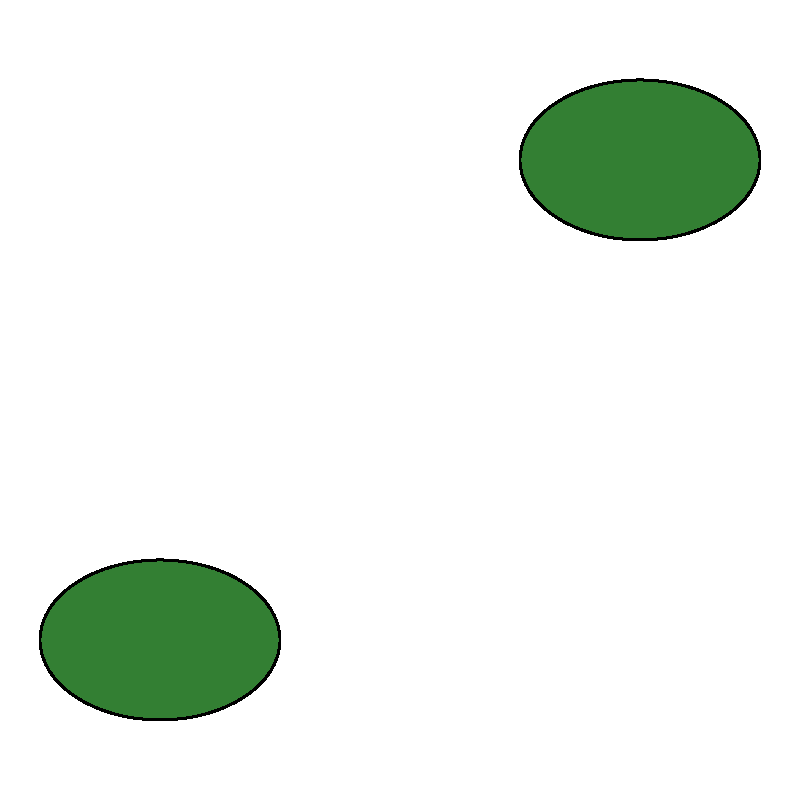Based on the aerial imagery provided, which sustainable land use practice is most prominently represented in this indigenous community? To determine the most prominently represented sustainable land use practice, we need to analyze the aerial imagery:

1. Identify the elements in the image:
   - Green elliptical shapes represent forested areas
   - Yellow polygonal shape represents crop areas
   - Blue semi-circular shape represents a water body
   - Brown polygonal shape represents a settlement

2. Assess the relative sizes and positions of these elements:
   - Forested areas are present in two locations, covering a significant portion of the image
   - Crop area is centrally located and occupies a moderate amount of space
   - Water body is relatively small and located at the edge
   - Settlement is small and positioned at one corner

3. Consider sustainable land use practices:
   - Forest conservation is crucial for biodiversity and carbon sequestration
   - Crop cultivation, if done sustainably, can provide food security
   - Water management is important but not prominently featured here
   - The settlement is small, indicating minimal urban expansion

4. Evaluate the prominence:
   - Forested areas are the largest and most distributed element in the image

5. Conclusion:
   The most prominently represented sustainable land use practice is forest conservation, as evidenced by the significant presence of forested areas in the aerial imagery.
Answer: Forest conservation 